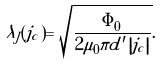<formula> <loc_0><loc_0><loc_500><loc_500>\lambda _ { J } ( j _ { c } ) = \sqrt { \frac { \Phi _ { 0 } } { 2 \mu _ { 0 } \pi d ^ { \prime } \left | j _ { c } \right | } } .</formula> 